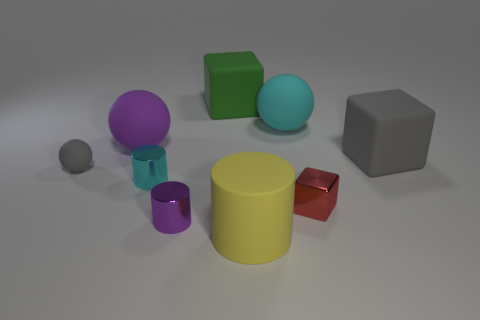How many other things are there of the same color as the small block? There are no other items with the exact color as the small green block in the image. 